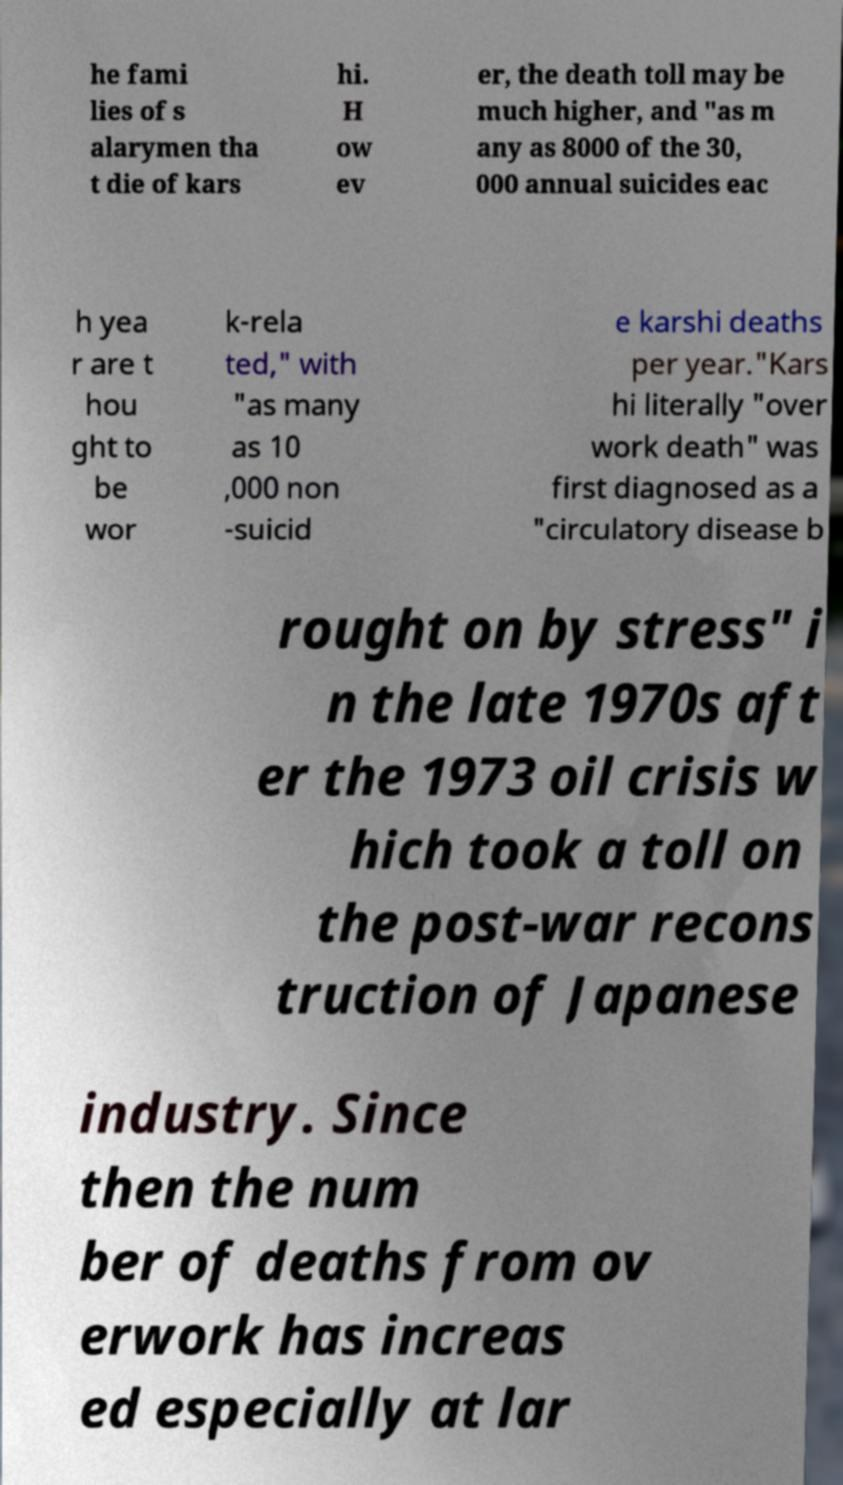I need the written content from this picture converted into text. Can you do that? he fami lies of s alarymen tha t die of kars hi. H ow ev er, the death toll may be much higher, and "as m any as 8000 of the 30, 000 annual suicides eac h yea r are t hou ght to be wor k-rela ted," with "as many as 10 ,000 non -suicid e karshi deaths per year."Kars hi literally "over work death" was first diagnosed as a "circulatory disease b rought on by stress" i n the late 1970s aft er the 1973 oil crisis w hich took a toll on the post-war recons truction of Japanese industry. Since then the num ber of deaths from ov erwork has increas ed especially at lar 